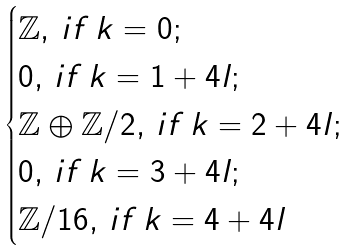Convert formula to latex. <formula><loc_0><loc_0><loc_500><loc_500>\begin{cases} \mathbb { Z } , \, i f \, k = 0 ; \\ 0 , \, i f \, k = 1 + 4 l ; \\ \mathbb { Z } \oplus \mathbb { Z } / 2 , \, i f \, k = 2 + 4 l ; \\ 0 , \, i f \, k = 3 + 4 l ; \\ \mathbb { Z } / 1 6 , \, i f \, k = 4 + 4 l \end{cases}</formula> 